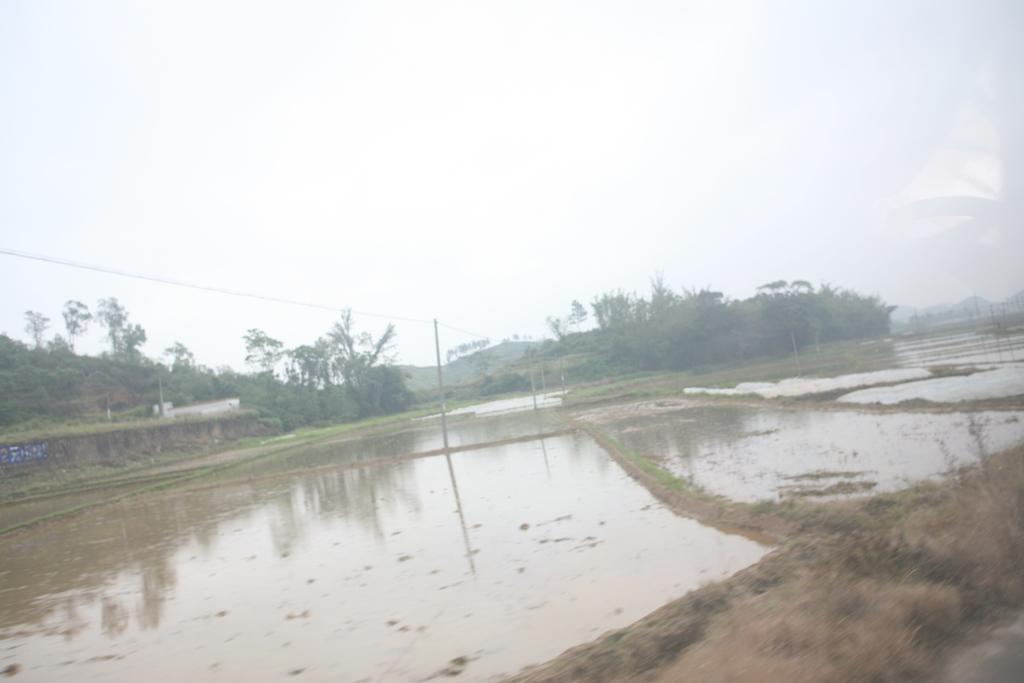Could you give a brief overview of what you see in this image? In this image there is water on the mud, there are poles, trees, a house and mountains and there is grass. 